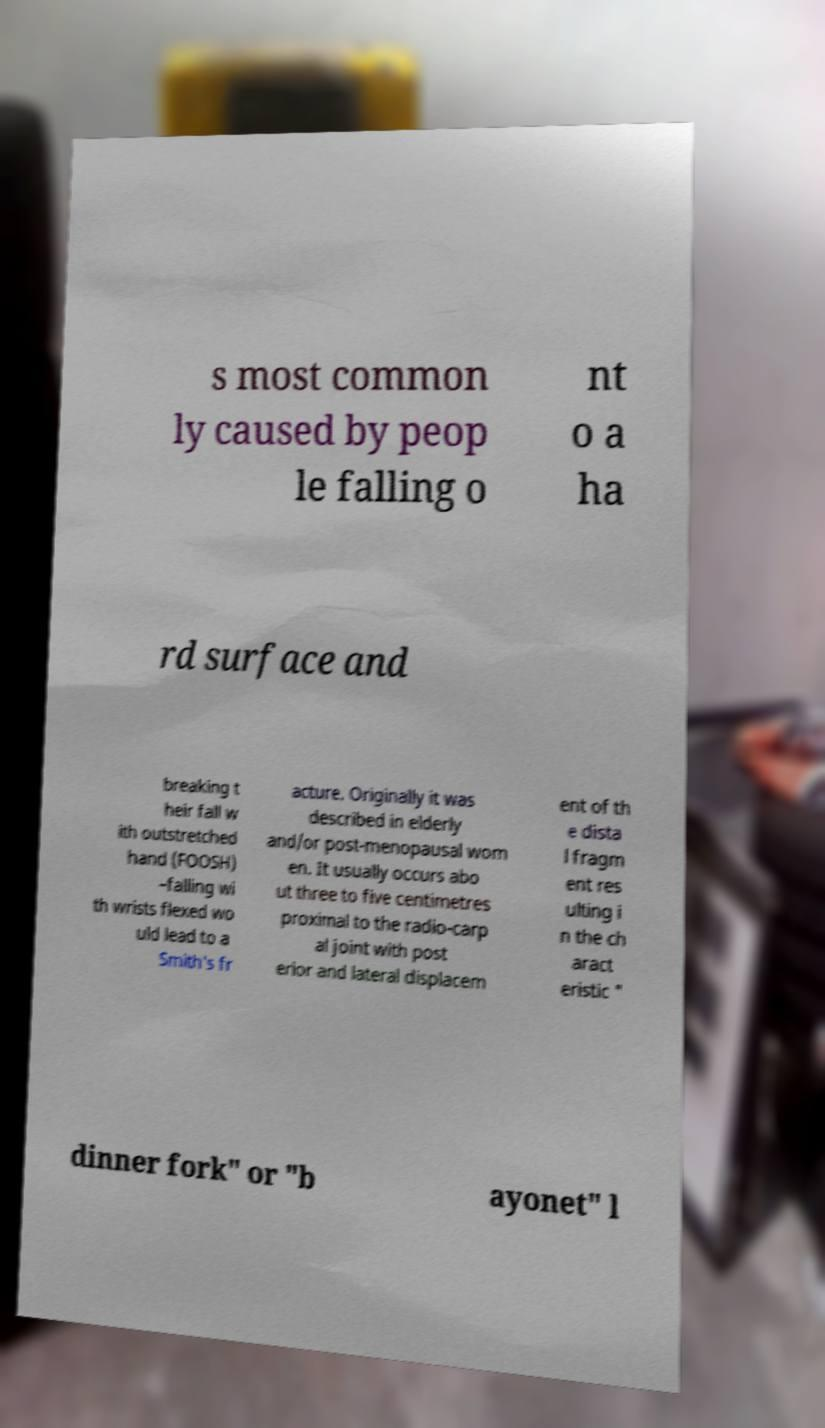There's text embedded in this image that I need extracted. Can you transcribe it verbatim? s most common ly caused by peop le falling o nt o a ha rd surface and breaking t heir fall w ith outstretched hand (FOOSH) –falling wi th wrists flexed wo uld lead to a Smith's fr acture. Originally it was described in elderly and/or post-menopausal wom en. It usually occurs abo ut three to five centimetres proximal to the radio-carp al joint with post erior and lateral displacem ent of th e dista l fragm ent res ulting i n the ch aract eristic " dinner fork" or "b ayonet" l 